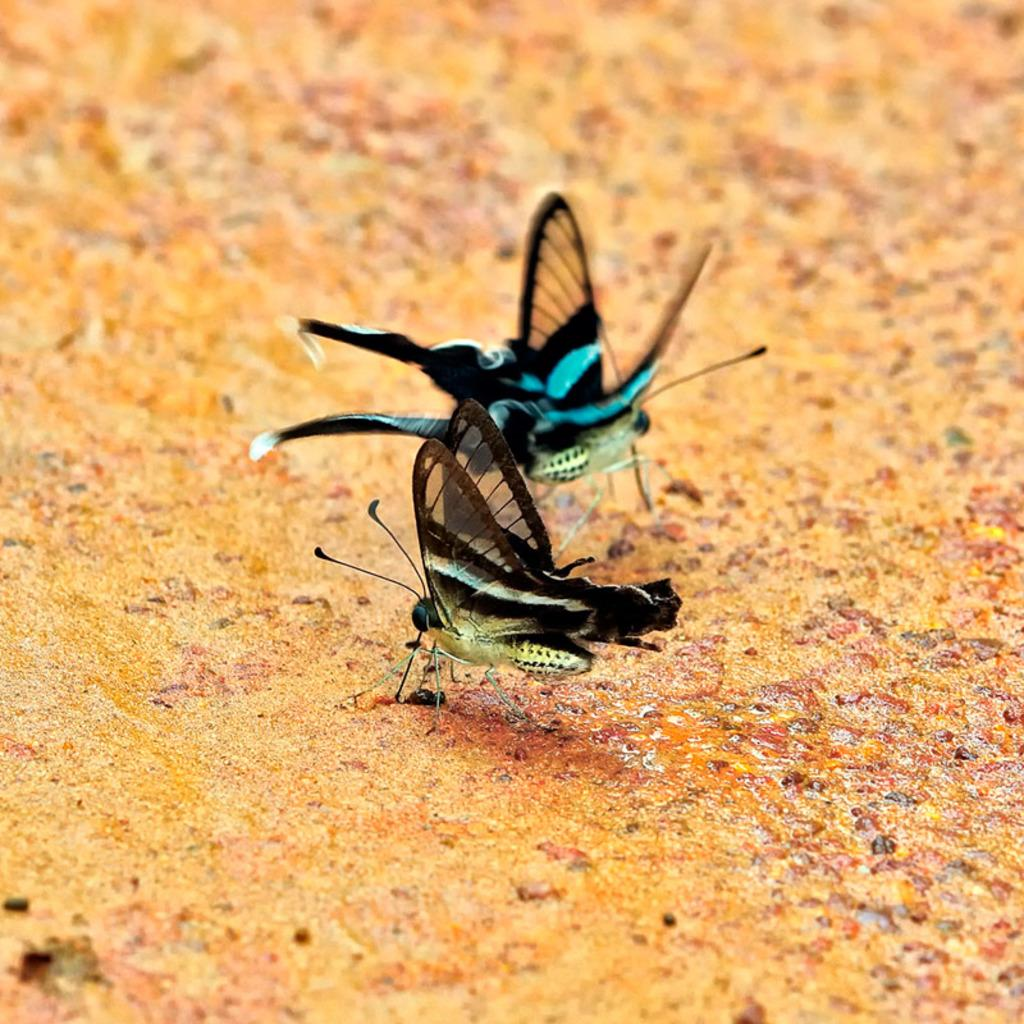What type of animals can be seen in the image? There are butterflies in the image. Where are the butterflies located in the image? The butterflies are on the ground in the image. What type of zephyr can be seen in the image? There is no zephyr present in the image. What type of connection can be seen between the butterflies in the image? The image does not depict any specific connection between the butterflies. 